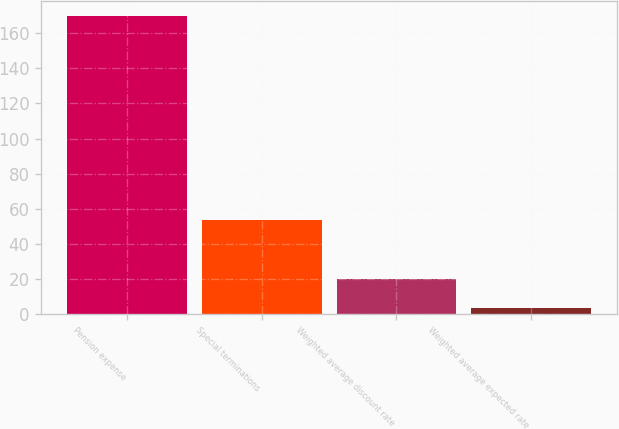<chart> <loc_0><loc_0><loc_500><loc_500><bar_chart><fcel>Pension expense<fcel>Special terminations<fcel>Weighted average discount rate<fcel>Weighted average expected rate<nl><fcel>169.7<fcel>53.57<fcel>20.39<fcel>3.8<nl></chart> 